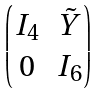<formula> <loc_0><loc_0><loc_500><loc_500>\begin{pmatrix} I _ { 4 } & \tilde { Y } \\ 0 & I _ { 6 } \end{pmatrix}</formula> 